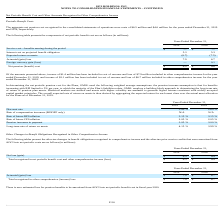According to Hc2 Holdings's financial document, What was the aggregate net pension cost recognized in December 2019? According to the financial document, $6.5 million. The relevant text states: "onsolidated statements of operations were costs of $6.5 million and $4.6 million for the years ended December 31, 2019 and 2018, respectively...." Also, What was the net pension cost in 2019? According to the financial document, $ 6.5 (in millions). The relevant text states: "Net pension (benefit) cost $ 6.5 $ 4.6..." Also, What was the Expected return on assets in 2019? According to the financial document, (6.7) (in millions). The relevant text states: "Expected return on assets (6.7) (7.5)..." Also, can you calculate: What was the average Interest cost on projected benefit obligation for 2018 and 2019? To answer this question, I need to perform calculations using the financial data. The calculation is: (5.3 + 5.3) / 2, which equals 5.3 (in millions). This is based on the information: "Interest cost on projected benefit obligation 5.3 5.3..." Also, can you calculate: What is the change in the expected return on assets from 2018 to 2019? Based on the calculation: -6.7 - (-7.5), the result is 0.8 (in millions). This is based on the information: "Expected return on assets (6.7) (7.5) Expected return on assets (6.7) (7.5)..." The key data points involved are: 6.7, 7.5. Also, can you calculate: What is the average actuarial (gain) loss for 2018 and 2019? To answer this question, I need to perform calculations using the financial data. The calculation is: (7.9 + 6.7) / 2, which equals 7.3 (in millions). This is based on the information: "Actuarial (gain) loss 7.9 6.7 Actuarial (gain) loss 7.9 6.7..." The key data points involved are: 6.7, 7.9. 